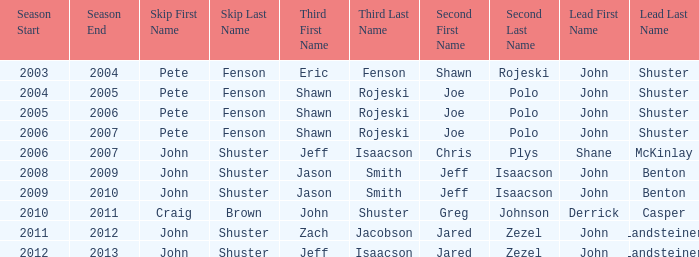Which season has Zach Jacobson in third? 2011–12. 